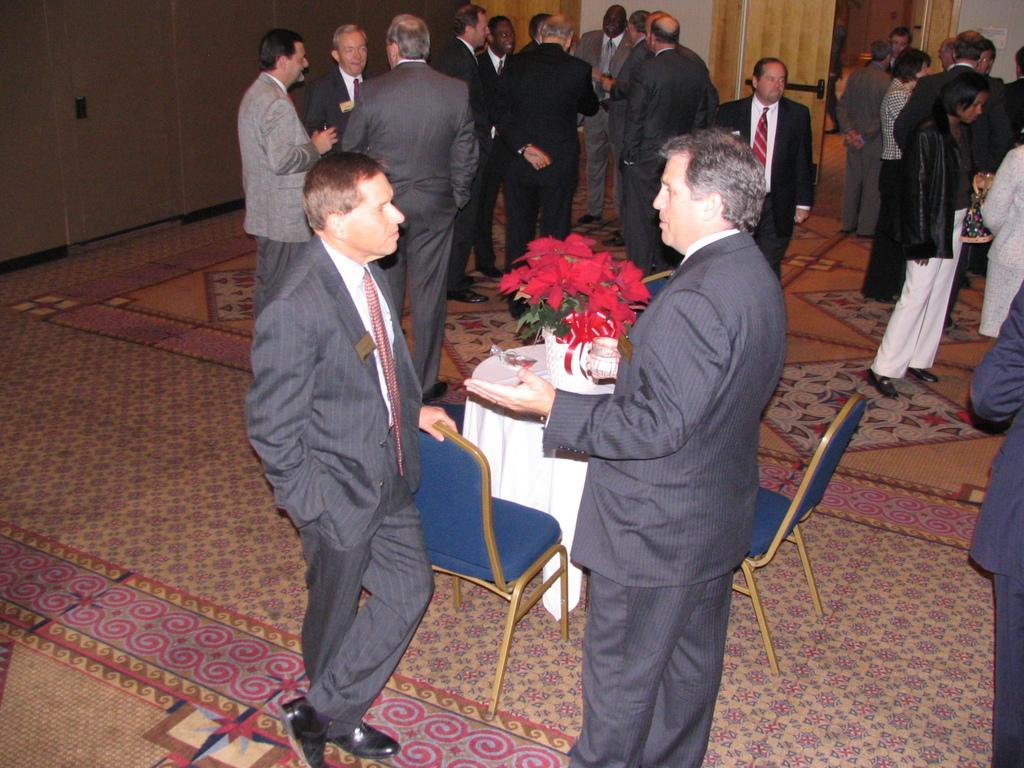Can you describe this image briefly? In this image we can see the people standing. We can also see the table which is covered with the cloth and there is a flower pot, chairs and also a door. We can also see the wall. At the bottom we can see the carpet on the floor. On the left we can see another door. 